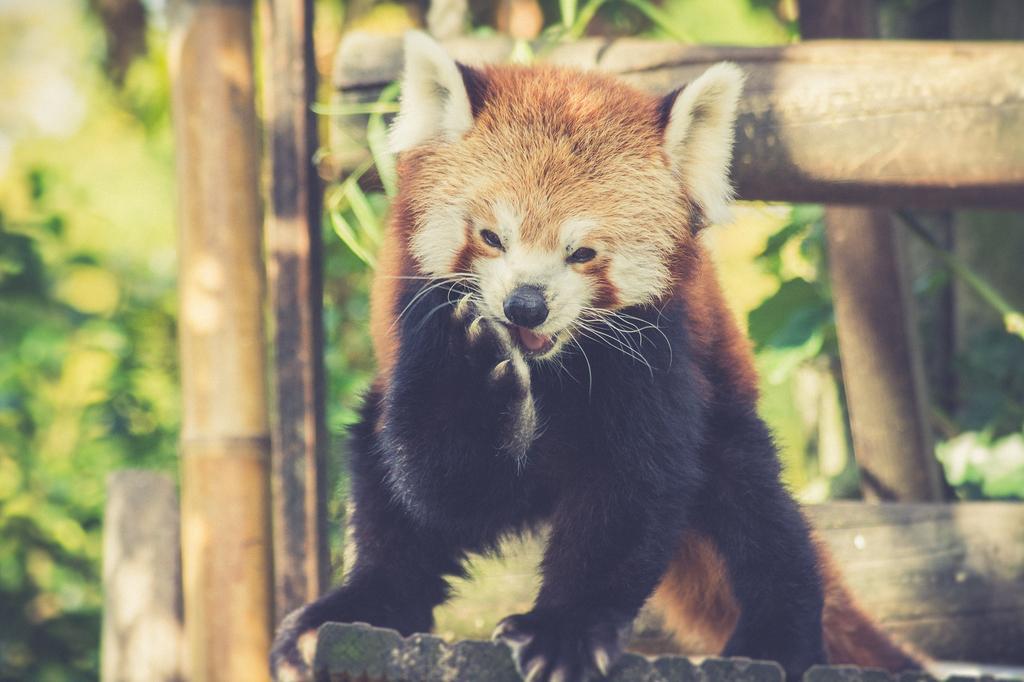How would you summarize this image in a sentence or two? In this image I can see an animal. In the background there are some trunks and plants. 